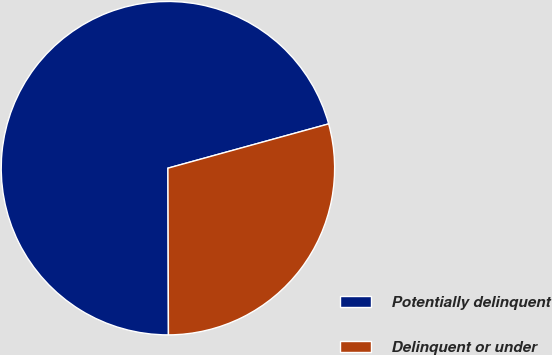Convert chart. <chart><loc_0><loc_0><loc_500><loc_500><pie_chart><fcel>Potentially delinquent<fcel>Delinquent or under<nl><fcel>70.77%<fcel>29.23%<nl></chart> 